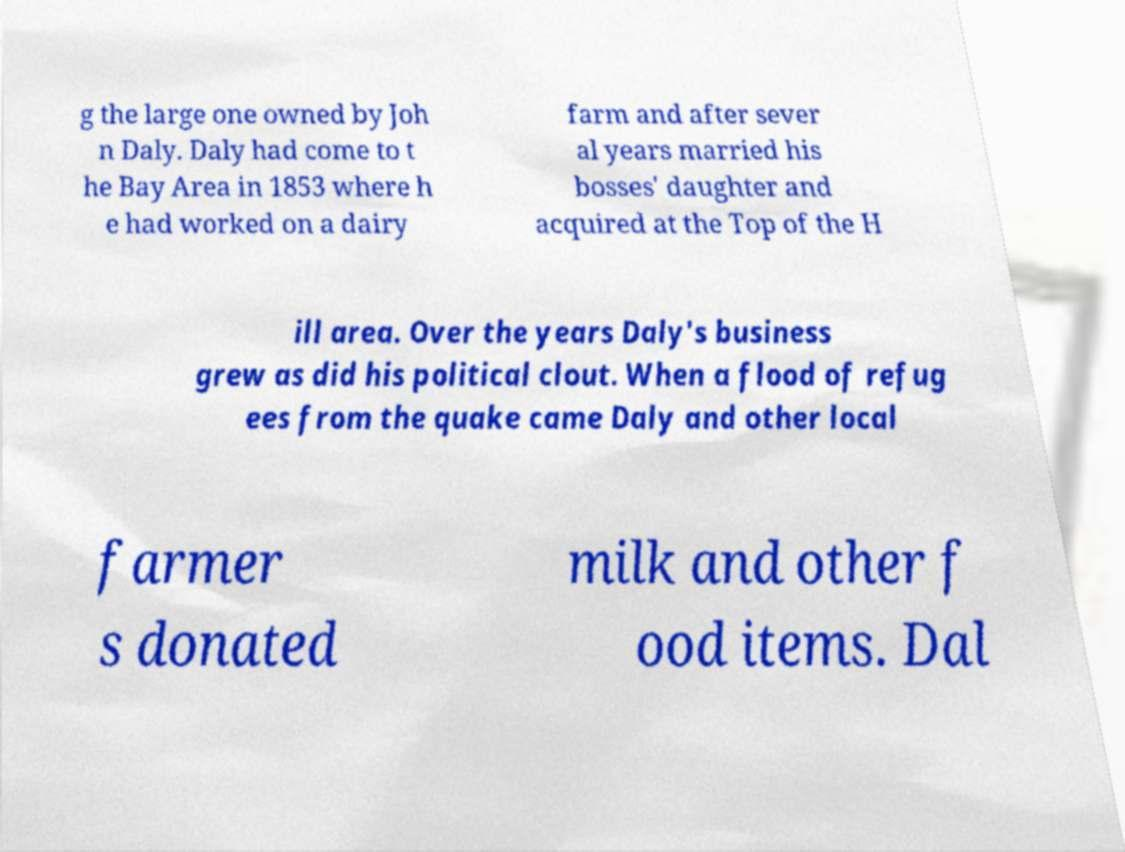For documentation purposes, I need the text within this image transcribed. Could you provide that? g the large one owned by Joh n Daly. Daly had come to t he Bay Area in 1853 where h e had worked on a dairy farm and after sever al years married his bosses' daughter and acquired at the Top of the H ill area. Over the years Daly's business grew as did his political clout. When a flood of refug ees from the quake came Daly and other local farmer s donated milk and other f ood items. Dal 